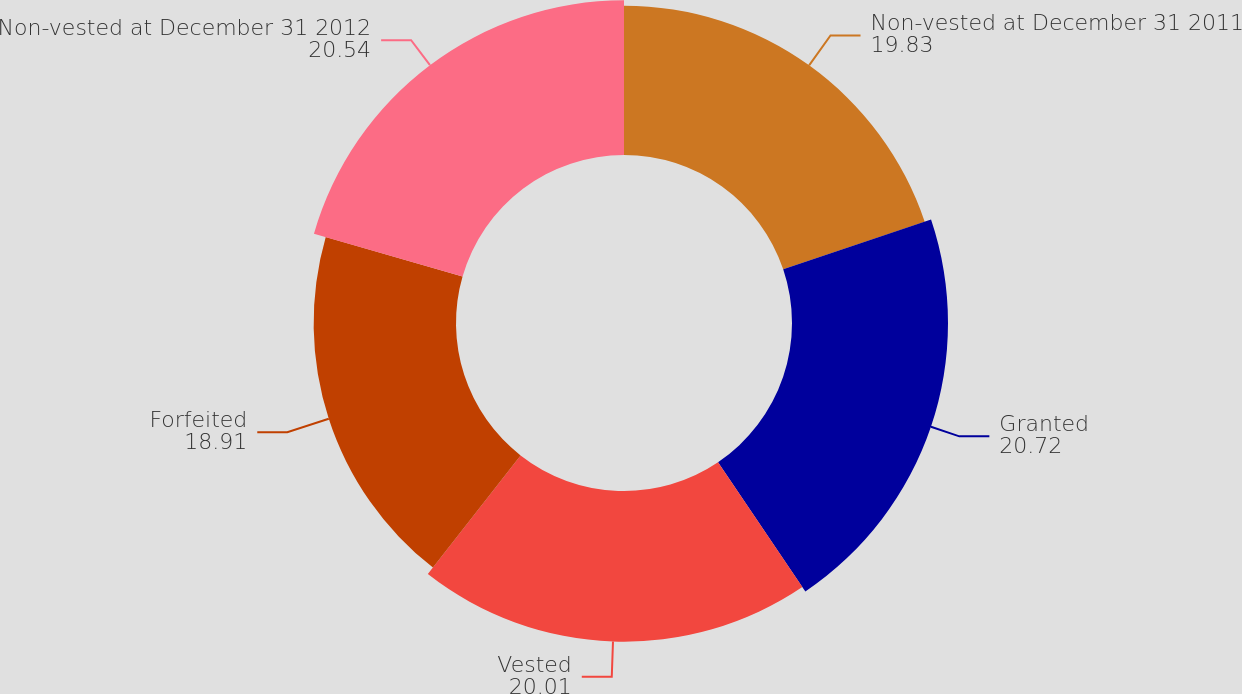Convert chart. <chart><loc_0><loc_0><loc_500><loc_500><pie_chart><fcel>Non-vested at December 31 2011<fcel>Granted<fcel>Vested<fcel>Forfeited<fcel>Non-vested at December 31 2012<nl><fcel>19.83%<fcel>20.72%<fcel>20.01%<fcel>18.91%<fcel>20.54%<nl></chart> 